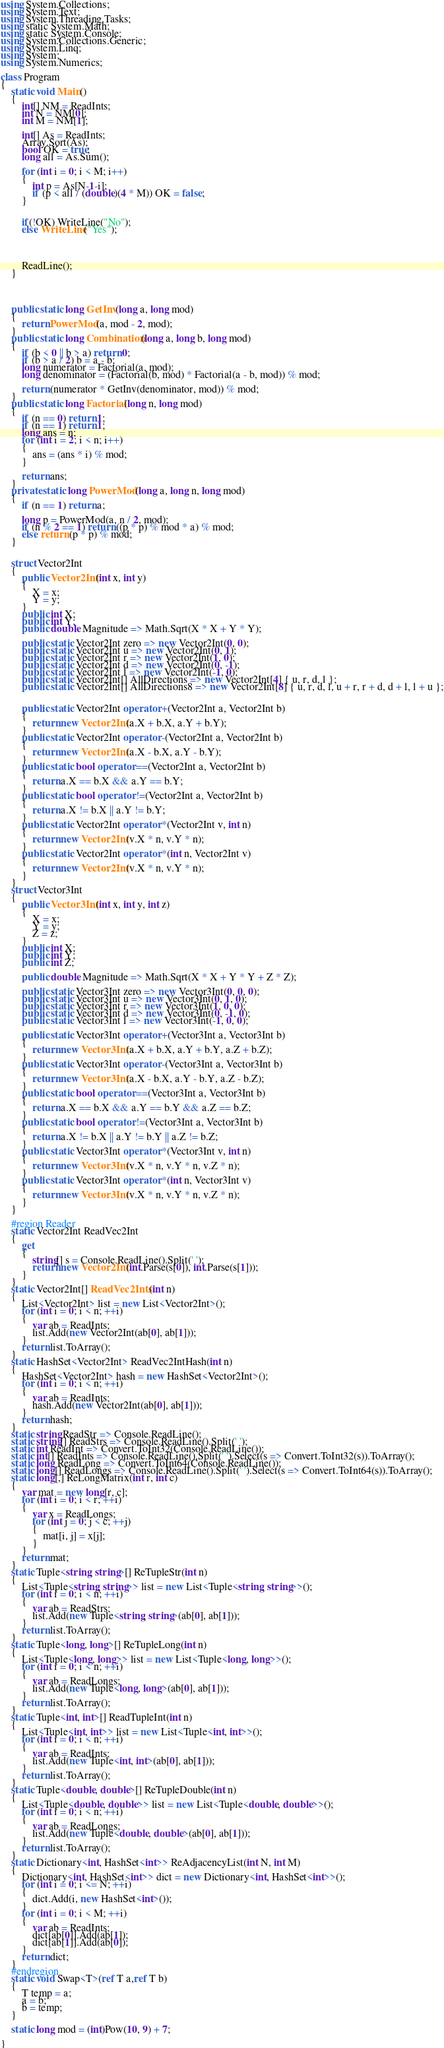<code> <loc_0><loc_0><loc_500><loc_500><_C#_>using System.Collections;
using System.Text;
using System.Threading.Tasks;
using static System.Math;
using static System.Console;
using System.Collections.Generic;
using System.Linq;
using System;
using System.Numerics;

class Program
{
    static void Main()
    {
        int[] NM = ReadInts;
        int N = NM[0];
        int M = NM[1];

        int[] As = ReadInts;
        Array.Sort(As);
        bool OK = true;
        long all = As.Sum();

        for (int i = 0; i < M; i++)
        {
            int p = As[N-1-i];
            if (p < all / (double)(4 * M)) OK = false;
        }


        if(!OK) WriteLine("No");
        else WriteLine("Yes");




        ReadLine();
    }

  


    public static long GetInv(long a, long mod)
    {
        return PowerMod(a, mod - 2, mod);
    }
    public static long Combination(long a, long b, long mod)
    {
        if (b < 0 || b > a) return 0;
        if (b > a / 2) b = a - b;
        long numerator = Factorial(a, mod);
        long denominator = (Factorial(b, mod) * Factorial(a - b, mod)) % mod;

        return (numerator * GetInv(denominator, mod)) % mod;
    }
    public static long Factorial(long n, long mod)
    {
        if (n == 0) return 1;
        if (n == 1) return 1;
        long ans = n;
        for (int i = 2; i < n; i++)
        {
            ans = (ans * i) % mod;
        }

        return ans;
    }
    private static long PowerMod(long a, long n, long mod)
    {
        if (n == 1) return a;

        long p = PowerMod(a, n / 2, mod);
        if (n % 2 == 1) return ((p * p) % mod * a) % mod;
        else return (p * p) % mod;
    }


    struct Vector2Int
    {
        public Vector2Int(int x, int y)
        {
            X = x;
            Y = y;
        }
        public int X;
        public int Y;
        public double Magnitude => Math.Sqrt(X * X + Y * Y);

        public static Vector2Int zero => new Vector2Int(0, 0);
        public static Vector2Int u => new Vector2Int(0, 1);
        public static Vector2Int r => new Vector2Int(1, 0);
        public static Vector2Int d => new Vector2Int(0, -1);
        public static Vector2Int l => new Vector2Int(-1, 0);
        public static Vector2Int[] AllDirections => new Vector2Int[4] { u, r, d, l };
        public static Vector2Int[] AllDirections8 => new Vector2Int[8] { u, r, d, l, u + r, r + d, d + l, l + u };


        public static Vector2Int operator +(Vector2Int a, Vector2Int b)
        {
            return new Vector2Int(a.X + b.X, a.Y + b.Y);
        }
        public static Vector2Int operator -(Vector2Int a, Vector2Int b)
        {
            return new Vector2Int(a.X - b.X, a.Y - b.Y);
        }
        public static bool operator ==(Vector2Int a, Vector2Int b)
        {
            return a.X == b.X && a.Y == b.Y;
        }
        public static bool operator !=(Vector2Int a, Vector2Int b)
        {
            return a.X != b.X || a.Y != b.Y;
        }
        public static Vector2Int operator *(Vector2Int v, int n)
        {
            return new Vector2Int(v.X * n, v.Y * n);
        }
        public static Vector2Int operator *(int n, Vector2Int v)
        {
            return new Vector2Int(v.X * n, v.Y * n);
        }
    }
    struct Vector3Int
    {
        public Vector3Int(int x, int y, int z)
        {
            X = x;
            Y = y;
            Z = z;
        }
        public int X;
        public int Y;
        public int Z;

        public double Magnitude => Math.Sqrt(X * X + Y * Y + Z * Z);

        public static Vector3Int zero => new Vector3Int(0, 0, 0);
        public static Vector3Int u => new Vector3Int(0, 1, 0);
        public static Vector3Int r => new Vector3Int(1, 0, 0);
        public static Vector3Int d => new Vector3Int(0, -1, 0);
        public static Vector3Int l => new Vector3Int(-1, 0, 0);

        public static Vector3Int operator +(Vector3Int a, Vector3Int b)
        {
            return new Vector3Int(a.X + b.X, a.Y + b.Y, a.Z + b.Z);
        }
        public static Vector3Int operator -(Vector3Int a, Vector3Int b)
        {
            return new Vector3Int(a.X - b.X, a.Y - b.Y, a.Z - b.Z);
        }
        public static bool operator ==(Vector3Int a, Vector3Int b)
        {
            return a.X == b.X && a.Y == b.Y && a.Z == b.Z;
        }
        public static bool operator !=(Vector3Int a, Vector3Int b)
        {
            return a.X != b.X || a.Y != b.Y || a.Z != b.Z;
        }
        public static Vector3Int operator *(Vector3Int v, int n)
        {
            return new Vector3Int(v.X * n, v.Y * n, v.Z * n);
        }
        public static Vector3Int operator *(int n, Vector3Int v)
        {
            return new Vector3Int(v.X * n, v.Y * n, v.Z * n);
        }
    }

    #region Reader
    static Vector2Int ReadVec2Int
    {
        get
        {
            string[] s = Console.ReadLine().Split(' ');
            return new Vector2Int(int.Parse(s[0]), int.Parse(s[1]));
        }
    }
    static Vector2Int[] ReadVec2Ints(int n)
    {
        List<Vector2Int> list = new List<Vector2Int>();
        for (int i = 0; i < n; ++i)
        {
            var ab = ReadInts;
            list.Add(new Vector2Int(ab[0], ab[1]));
        }
        return list.ToArray();
    }
    static HashSet<Vector2Int> ReadVec2IntHash(int n)
    {
        HashSet<Vector2Int> hash = new HashSet<Vector2Int>();
        for (int i = 0; i < n; ++i)
        {
            var ab = ReadInts;
            hash.Add(new Vector2Int(ab[0], ab[1]));
        }
        return hash;
    }
    static string ReadStr => Console.ReadLine();
    static string[] ReadStrs => Console.ReadLine().Split(' ');
    static int ReadInt => Convert.ToInt32(Console.ReadLine());
    static int[] ReadInts => Console.ReadLine().Split(' ').Select(s => Convert.ToInt32(s)).ToArray();
    static long ReadLong => Convert.ToInt64(Console.ReadLine());
    static long[] ReadLongs => Console.ReadLine().Split(' ').Select(s => Convert.ToInt64(s)).ToArray();
    static long[,] ReLongMatrix(int r, int c)
    {
        var mat = new long[r, c];
        for (int i = 0; i < r; ++i)
        {
            var x = ReadLongs;
            for (int j = 0; j < c; ++j)
            {
                mat[i, j] = x[j];
            }
        }
        return mat;
    }
    static Tuple<string, string>[] ReTupleStr(int n)
    {
        List<Tuple<string, string>> list = new List<Tuple<string, string>>();
        for (int i = 0; i < n; ++i)
        {
            var ab = ReadStrs;
            list.Add(new Tuple<string, string>(ab[0], ab[1]));
        }
        return list.ToArray();
    }
    static Tuple<long, long>[] ReTupleLong(int n)
    {
        List<Tuple<long, long>> list = new List<Tuple<long, long>>();
        for (int i = 0; i < n; ++i)
        {
            var ab = ReadLongs;
            list.Add(new Tuple<long, long>(ab[0], ab[1]));
        }
        return list.ToArray();
    }
    static Tuple<int, int>[] ReadTupleInt(int n)
    {
        List<Tuple<int, int>> list = new List<Tuple<int, int>>();
        for (int i = 0; i < n; ++i)
        {
            var ab = ReadInts;
            list.Add(new Tuple<int, int>(ab[0], ab[1]));
        }
        return list.ToArray();
    }
    static Tuple<double, double>[] ReTupleDouble(int n)
    {
        List<Tuple<double, double>> list = new List<Tuple<double, double>>();
        for (int i = 0; i < n; ++i)
        {
            var ab = ReadLongs;
            list.Add(new Tuple<double, double>(ab[0], ab[1]));
        }
        return list.ToArray();
    }
    static Dictionary<int, HashSet<int>> ReAdjacencyList(int N, int M)
    {
        Dictionary<int, HashSet<int>> dict = new Dictionary<int, HashSet<int>>();
        for (int i = 0; i <= N; ++i)
        {
            dict.Add(i, new HashSet<int>());
        }
        for (int i = 0; i < M; ++i)
        {
            var ab = ReadInts;
            dict[ab[0]].Add(ab[1]);
            dict[ab[1]].Add(ab[0]);
        }
        return dict;
    }
    #endregion
    static void Swap<T>(ref T a,ref T b)
    {
        T temp = a;
        a = b;
        b = temp;
    }

    static long mod = (int)Pow(10, 9) + 7;

}</code> 